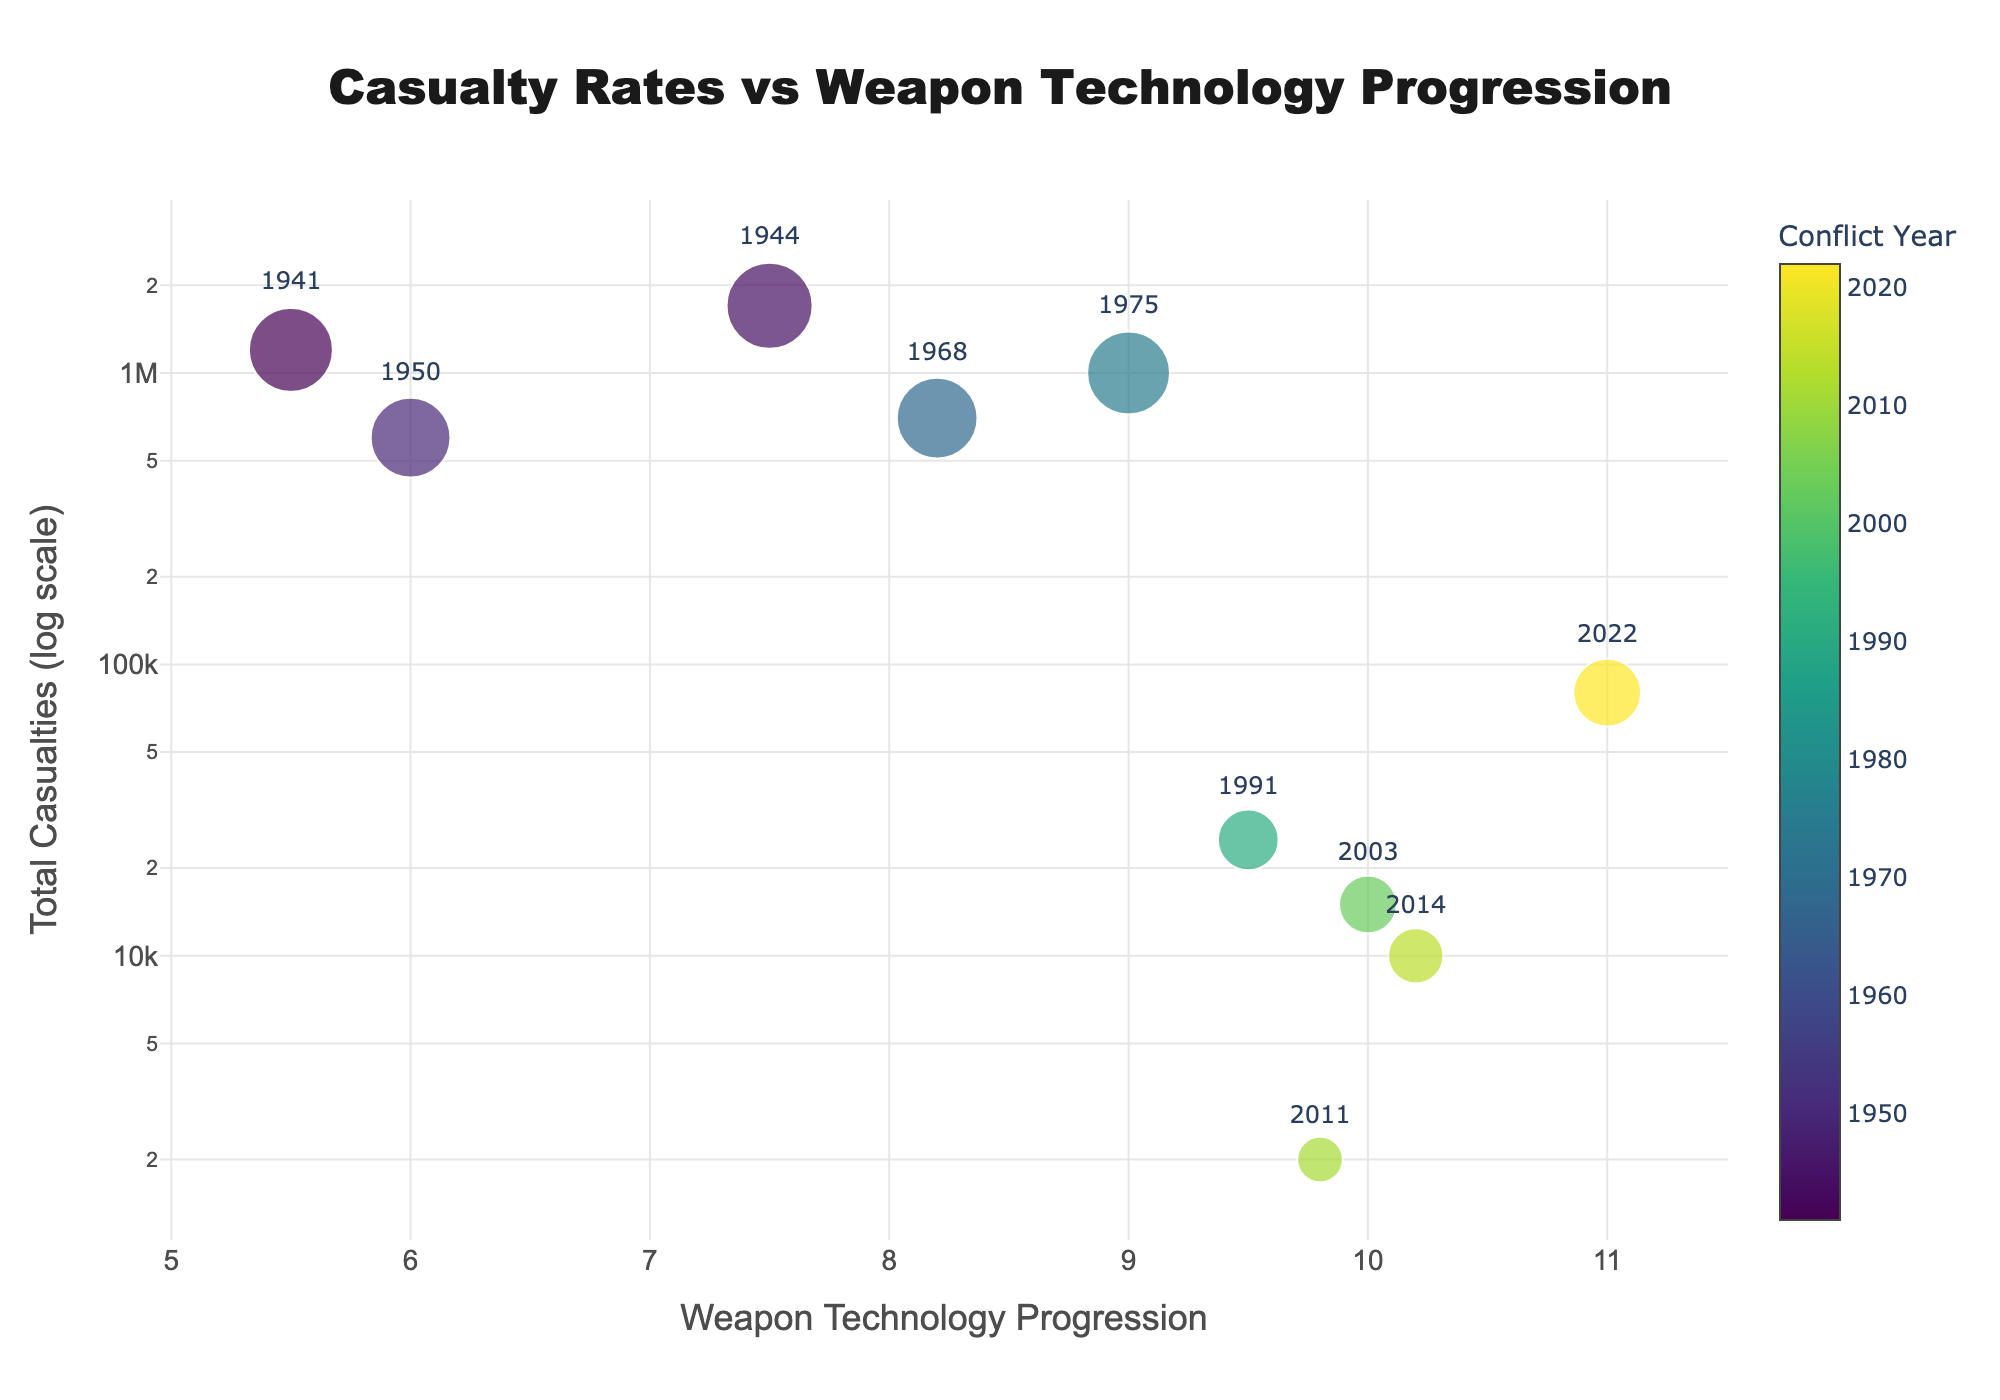What is the title of the figure? The title of a figure is typically found at the top, centrally located, and formatted to stand out. The title here is "Casualty Rates vs Weapon Technology Progression".
Answer: Casualty Rates vs Weapon Technology Progression How are the years represented in the figure? The years are represented as text labels positioned above the markers for each data point, indicating specific conflict years.
Answer: As text labels above data points What does the color bar represent? The color bar on the right side of the figure typically indicates the color mapping for a variable. Here, it represents the conflict years.
Answer: Conflict years Which year had the highest total casualties and what was the weapon technology progression during that year? By looking at the scatter plot, find the highest y-value (total casualties) and note the corresponding year. The point for the year 1944 is the highest, with 1,700,000 casualties and a weapon technology progression of 7.5.
Answer: 1944, 7.5 What trend can be observed between weapon technology progression and total casualties? Observing the scatter plot, there seems to be a general trend that as weapon technology progression increases, the total number of casualties decreases.
Answer: Increase in technology, decrease in casualties Which conflict year had the lowest total casualties and what is the associated weapon technology progression? Locate the point with the lowest y-value (total casualties) on the scatter plot. The smallest value corresponds to the year 2011, with 2,000 casualties and a weapon technology progression of 9.8.
Answer: 2011, 9.8 What is different about the y-axis on this plot compared to a normal scatter plot? The y-axis is set to a logarithmic scale rather than a linear scale, allowing better visualization of values spanning several orders of magnitude.
Answer: Logarithmic scale Compare the casualty rates between the conflicts in 1991 and 2022. Locate the points for 1991 and 2022 and compare their y-values. 1991 had 25,000 casualties, while 2022 had 80,000 casualties, indicating higher casualties in 2022.
Answer: 1991: 25,000; 2022: 80,000 What is the difference in weapon technology progression between 1941 and 2022? Find the weapon technology progression for both years: 1941 has 5.5, and 2022 has 11. The difference is 11 - 5.5 = 5.5.
Answer: 5.5 Is there any year where a higher weapon technology progression does not follow the general trend of lower casualties? Identify any outliers where high weapon technology progression aligns with higher casualties. For instance, the year 2022 has relatively higher casualties (80,000) despite an advanced weapon technology progression of 11.
Answer: 2022 